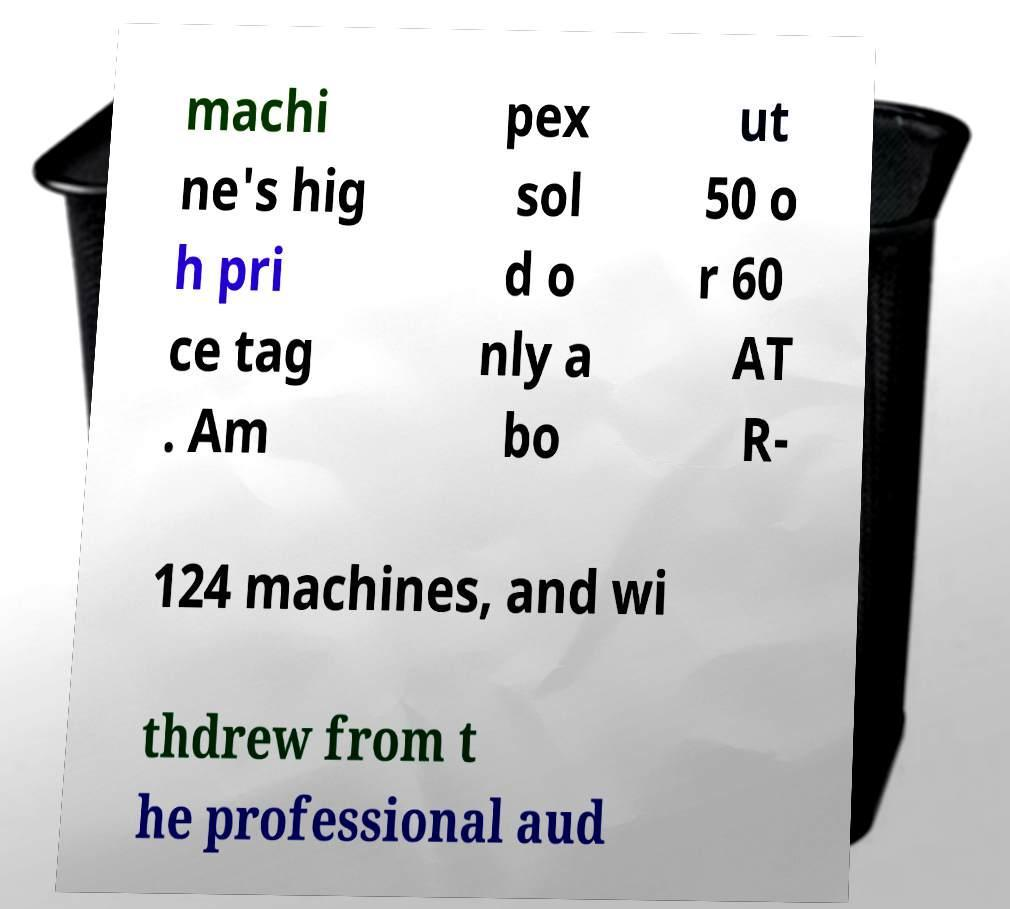There's text embedded in this image that I need extracted. Can you transcribe it verbatim? machi ne's hig h pri ce tag . Am pex sol d o nly a bo ut 50 o r 60 AT R- 124 machines, and wi thdrew from t he professional aud 